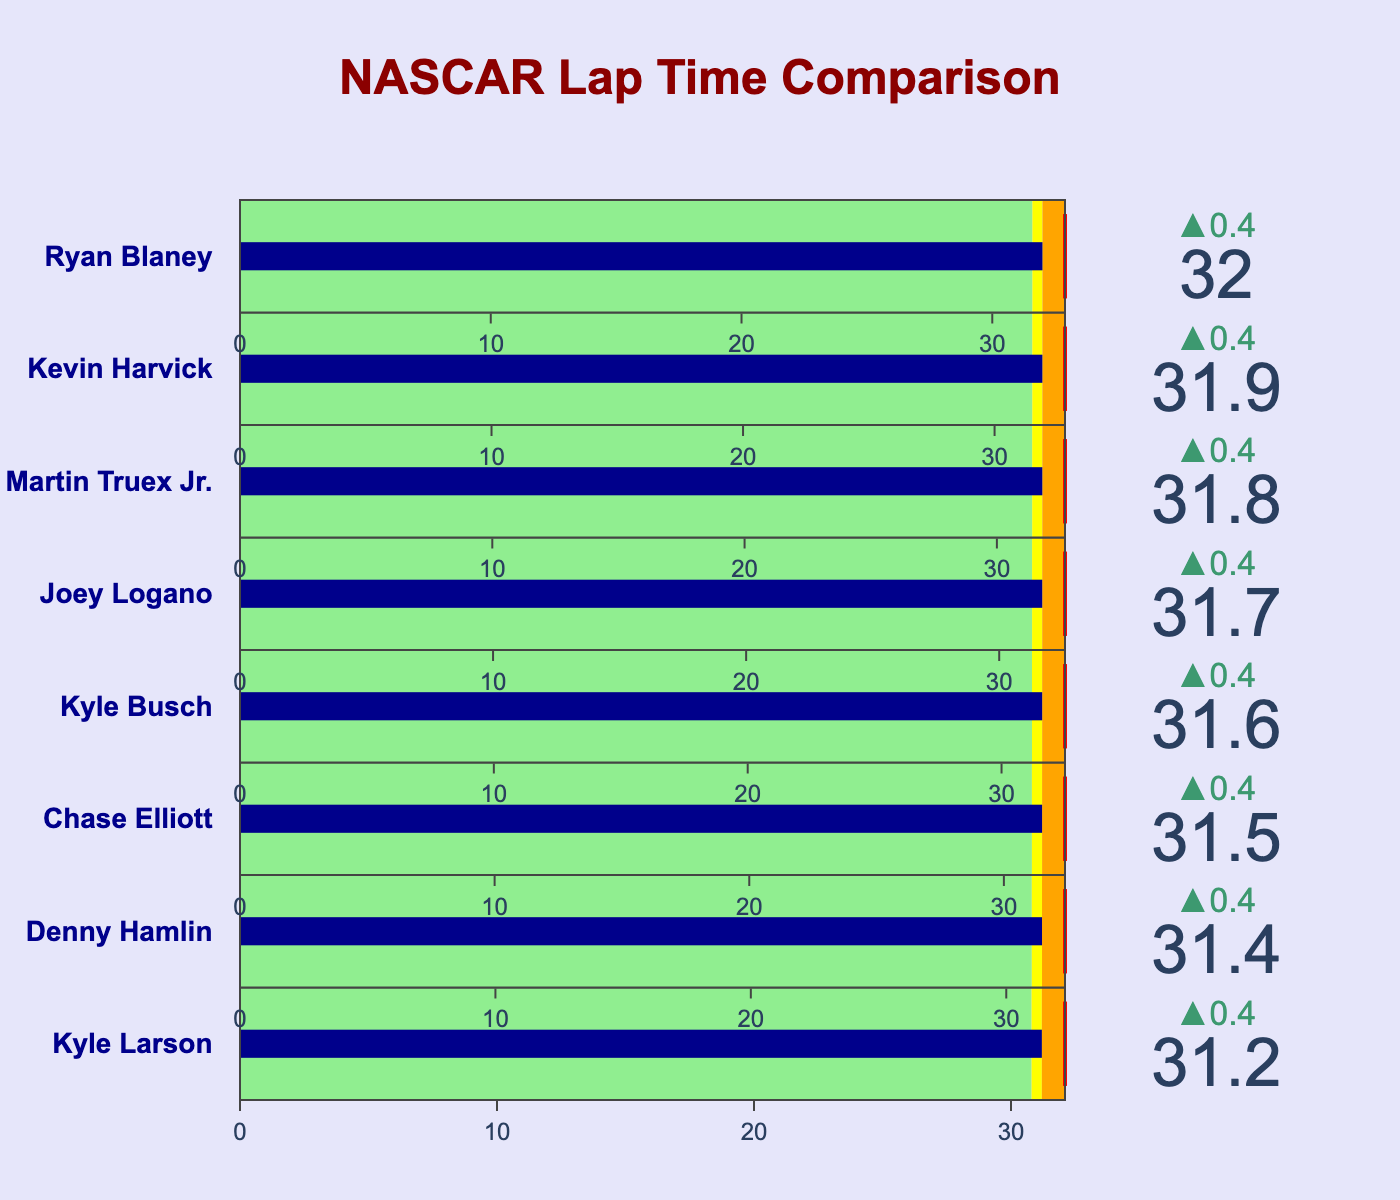what is the title of the plot? The title is displayed prominently at the top of the plot. It is written in large, bold text.
Answer: NASCAR Lap Time Comparison How many drivers' lap times are compared in the chart? The chart contains one bullet indicator for each driver. There are indicators labeled with drivers' names.
Answer: 8 Which driver has the worst average lap time? To find this, look at the value indicators in each bullet chart. Compare which driver has the highest average lap time.
Answer: Ryan Blaney What is Kyle Larson's best lap time? Locate Kyle Larson's name on the chart. The best lap time is indicated by the green section of the bullet chart.
Answer: 30.8 How does Denny Hamlin's best lap time compare to Chase Elliott's best lap time? Compare the green sections of Denny Hamlin and Chase Elliott. The length will give a clear comparison of best lap times.
Answer: Denny Hamlin's best lap time is 31.0, and Chase Elliott's is 31.1. Denny Hamlin's is faster Which driver has the most consistent lap times? Consistency can be judged by the range between the best and worst lap times. The smallest range indicates consistency.
Answer: Kyle Larson (Range: 32.1 - 30.8 = 1.3) To which driver does the worst lap time belong? Look at the maximum end of each driver’s bullet chart, marked by the red line. Identify the highest value among these.
Answer: Ryan Blaney with 32.9 What is the difference between Joey Logano's best and worst lap times? Identify Joey Logano's green section for the best and the end of the bullet chart marked by the red line for the worst. Subtract these values.
Answer: 32.6 - 31.3 = 1.3 Who had a better average lap time, Martin Truex Jr. or Kevin Harvick? Compare the average values marked in the bullet charts of Martin Truex Jr. and Kevin Harvick.
Answer: Martin Truex Jr. with 31.8, compared to Kevin Harvick's 31.9 By how much does Kyle Busch's best lap time differ from his average lap time? Locate Kyle Busch’s chart and compare his average lap time value with his best lap time in the green section. Subtract these values.
Answer: 31.6 - 31.2 = 0.4 